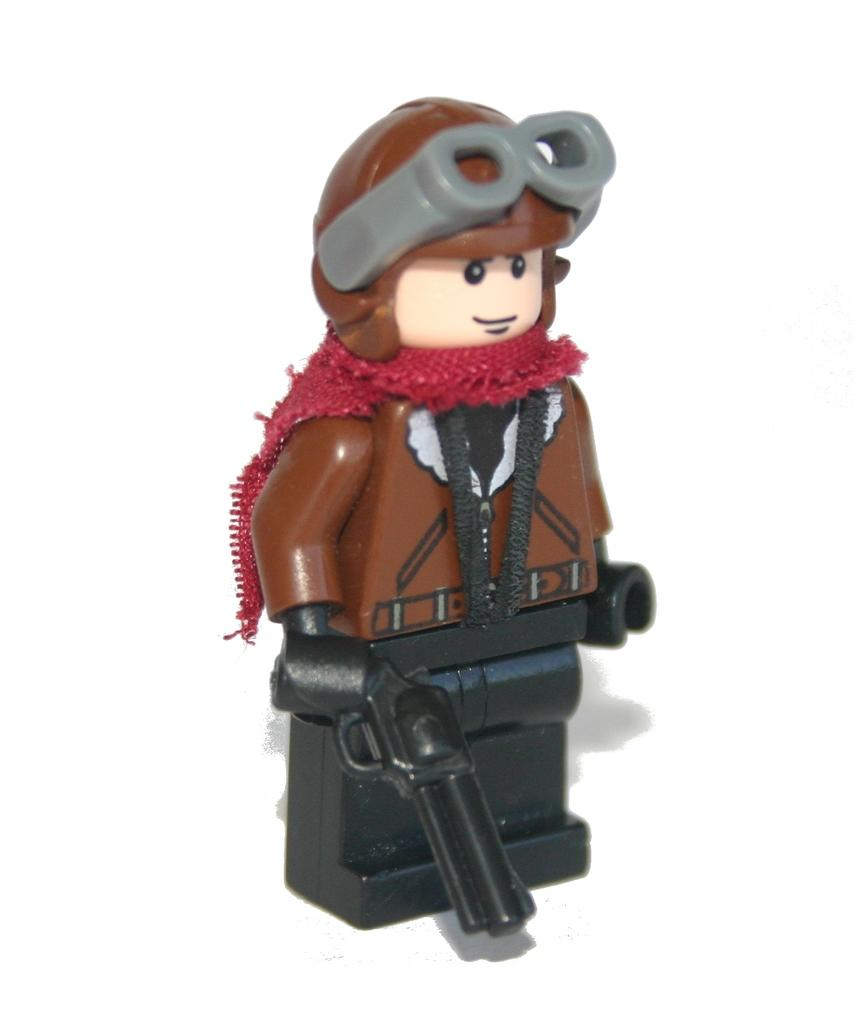What object can be seen in the image? There is a toy in the image. What is the toy holding in its hand? The toy is holding a gun in its hand. What color is the background of the image? The background of the image is white. What advice does the toy give in the image? The image does not depict the toy giving any advice; it only shows the toy holding a gun. 